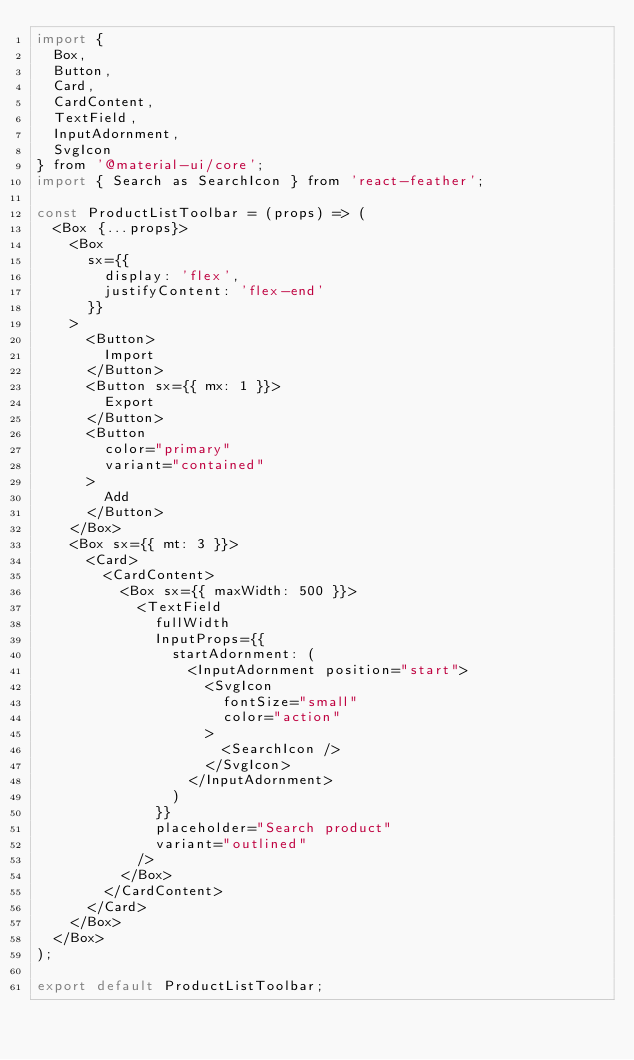<code> <loc_0><loc_0><loc_500><loc_500><_JavaScript_>import {
  Box,
  Button,
  Card,
  CardContent,
  TextField,
  InputAdornment,
  SvgIcon
} from '@material-ui/core';
import { Search as SearchIcon } from 'react-feather';

const ProductListToolbar = (props) => (
  <Box {...props}>
    <Box
      sx={{
        display: 'flex',
        justifyContent: 'flex-end'
      }}
    >
      <Button>
        Import
      </Button>
      <Button sx={{ mx: 1 }}>
        Export
      </Button>
      <Button
        color="primary"
        variant="contained"
      >
        Add
      </Button>
    </Box>
    <Box sx={{ mt: 3 }}>
      <Card>
        <CardContent>
          <Box sx={{ maxWidth: 500 }}>
            <TextField
              fullWidth
              InputProps={{
                startAdornment: (
                  <InputAdornment position="start">
                    <SvgIcon
                      fontSize="small"
                      color="action"
                    >
                      <SearchIcon />
                    </SvgIcon>
                  </InputAdornment>
                )
              }}
              placeholder="Search product"
              variant="outlined"
            />
          </Box>
        </CardContent>
      </Card>
    </Box>
  </Box>
);

export default ProductListToolbar;
</code> 